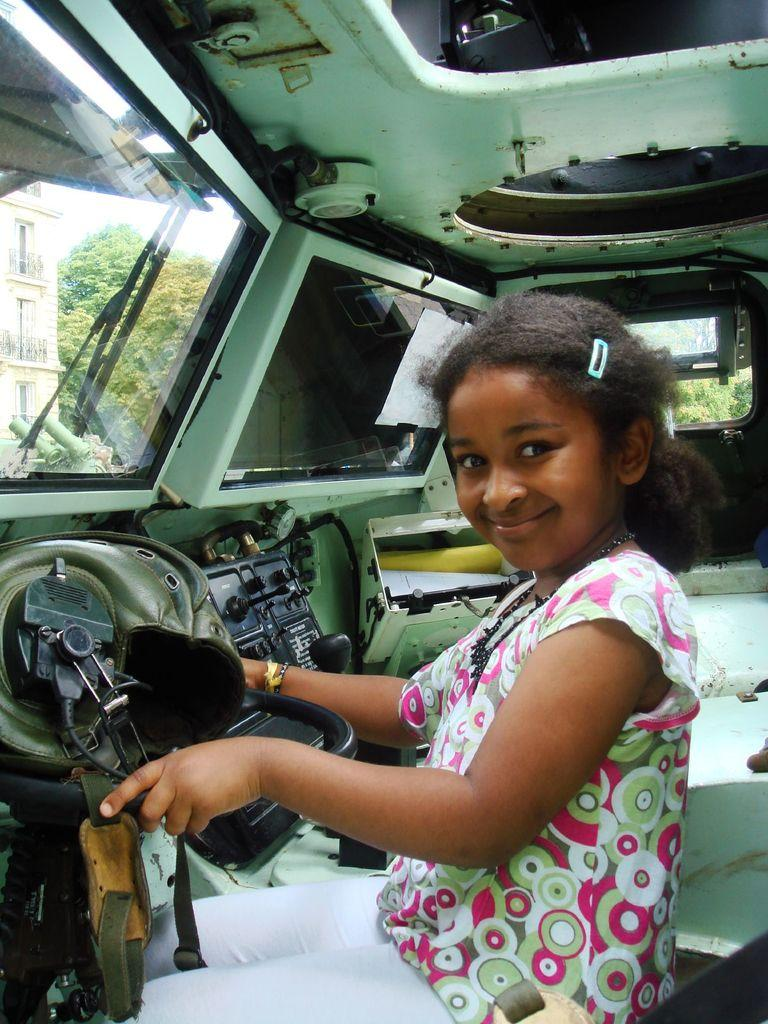Who is the main subject in the image? There is a small girl in the center of the image. What is the girl's position in the image? The girl appears to be sitting inside a vehicle. What can be seen outside the vehicle in the image? There is a building and trees visible outside the vehicle. What type of kettle is visible in the image? There is no kettle present in the image. Can you describe the girl's haircut in the image? The provided facts do not mention the girl's haircut, so it cannot be described. 